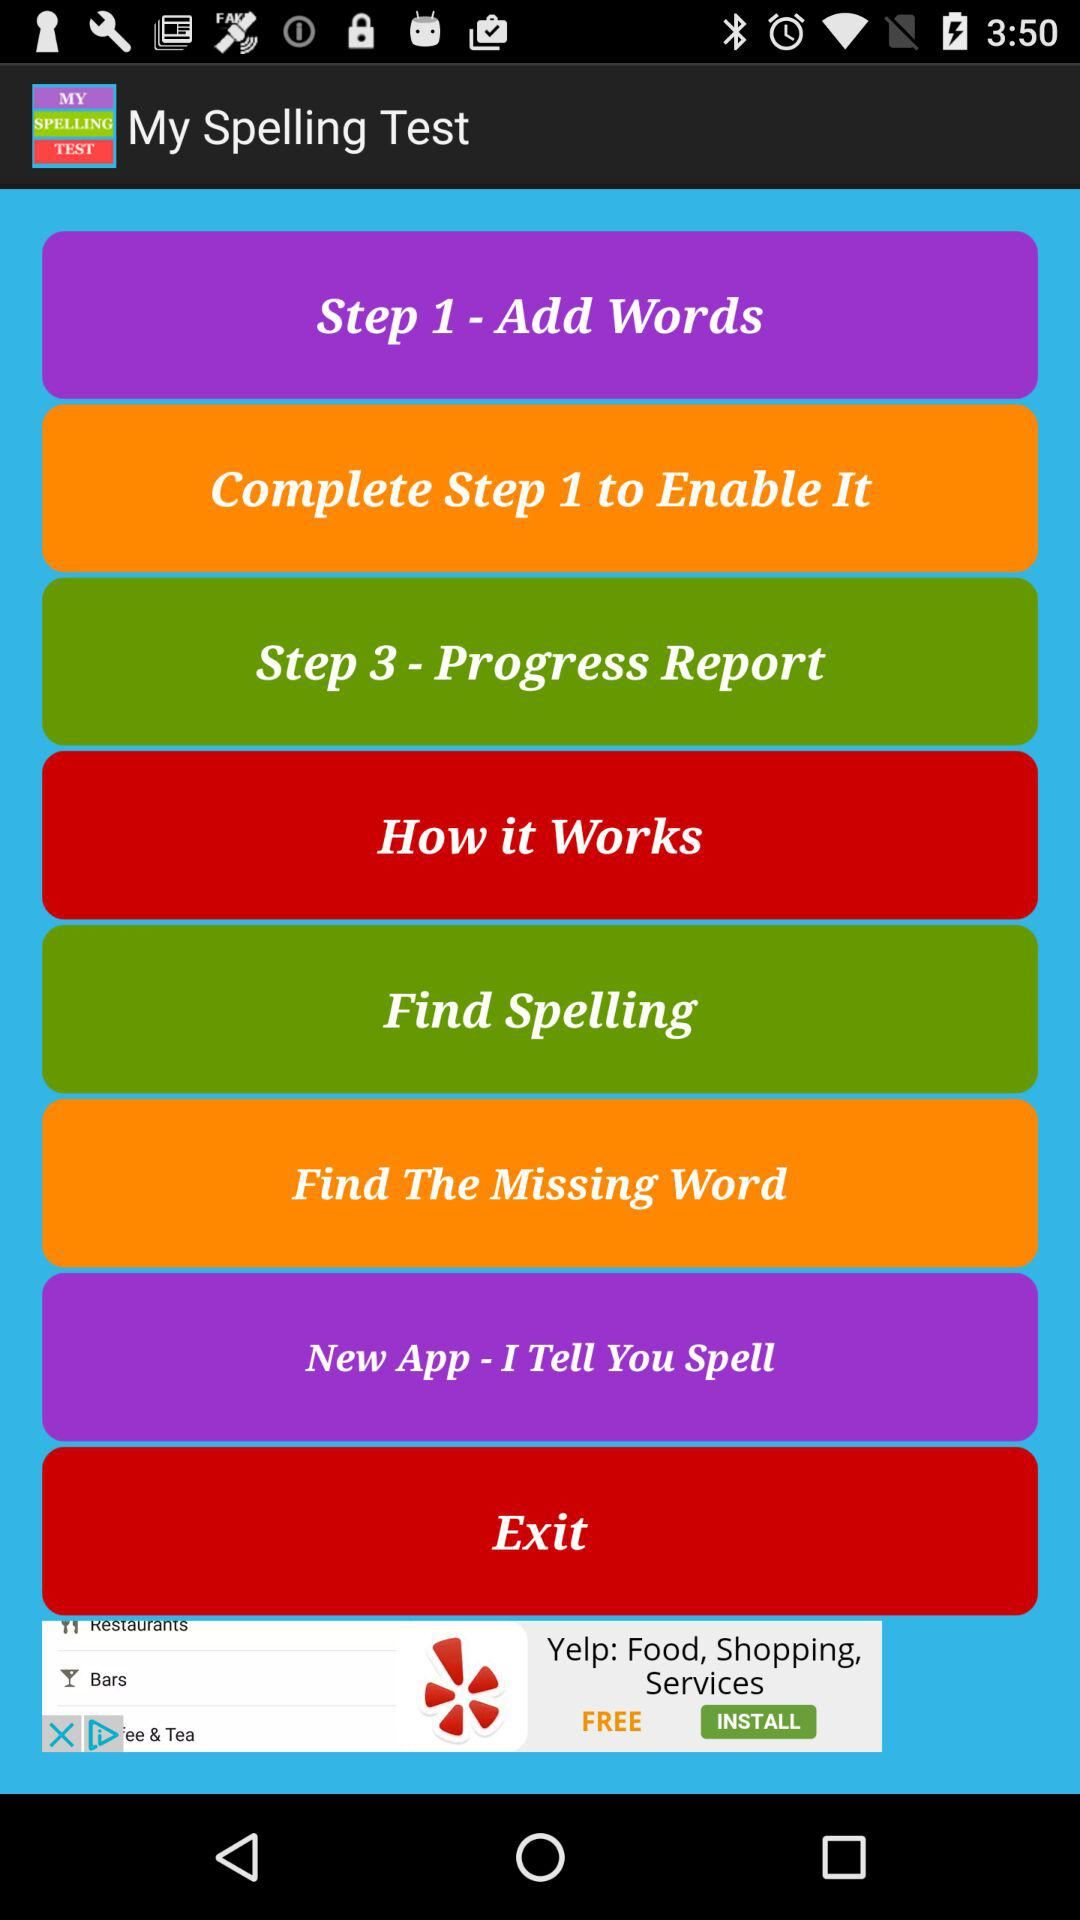What is the name of the application? The application name is "My Spelling Test". 